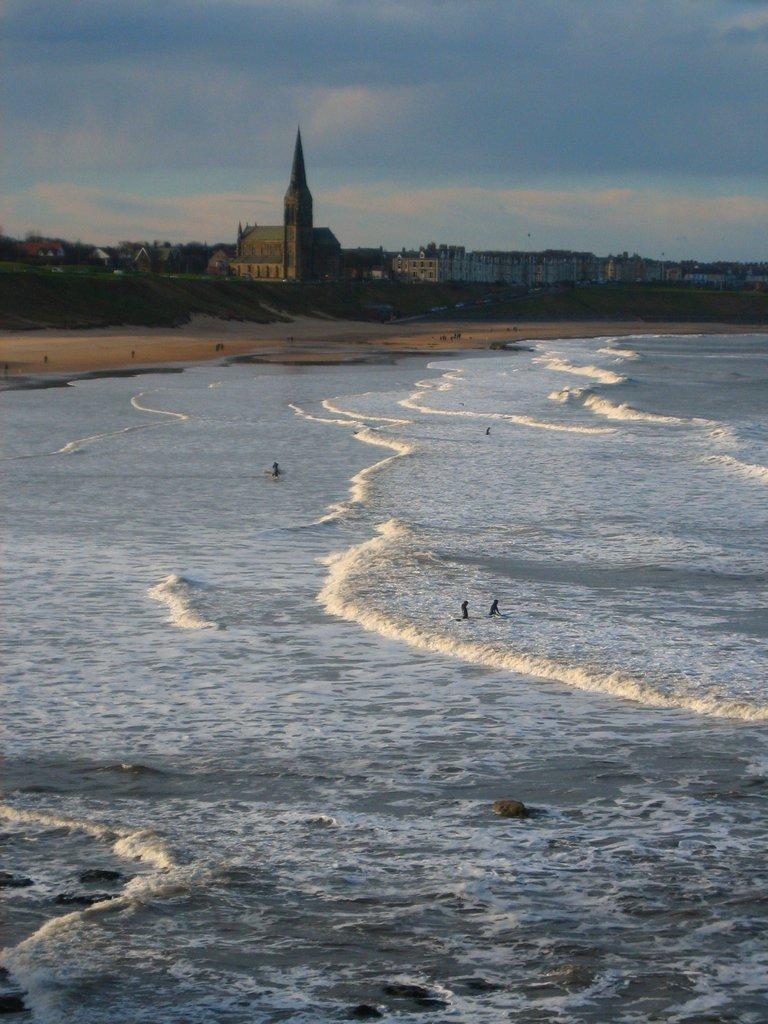What is the setting of the image? The image features persons on the sea and seashore. What can be seen on the beach? There are piles of sand in the image. What type of vegetation is present in the image? There are trees in the image. What structures are visible in the image? There are buildings in the image. What is visible in the sky in the image? The sky is visible in the image with clouds. What type of dolls can be seen playing in harmony in the image? There are no dolls present in the image, and the concept of harmony is not applicable to the scene depicted. 